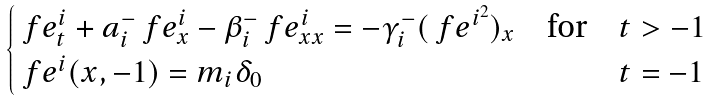Convert formula to latex. <formula><loc_0><loc_0><loc_500><loc_500>\begin{cases} \ f e ^ { i } _ { t } + a ^ { - } _ { i } \ f e ^ { i } _ { x } - \beta ^ { - } _ { i } \ f e ^ { i } _ { x x } = - \gamma ^ { - } _ { i } ( \ f e ^ { i ^ { 2 } } ) _ { x } \quad \text {for} & t > - 1 \\ \ f e ^ { i } ( x , - 1 ) = m _ { i } \delta _ { 0 } & t = - 1 \end{cases}</formula> 